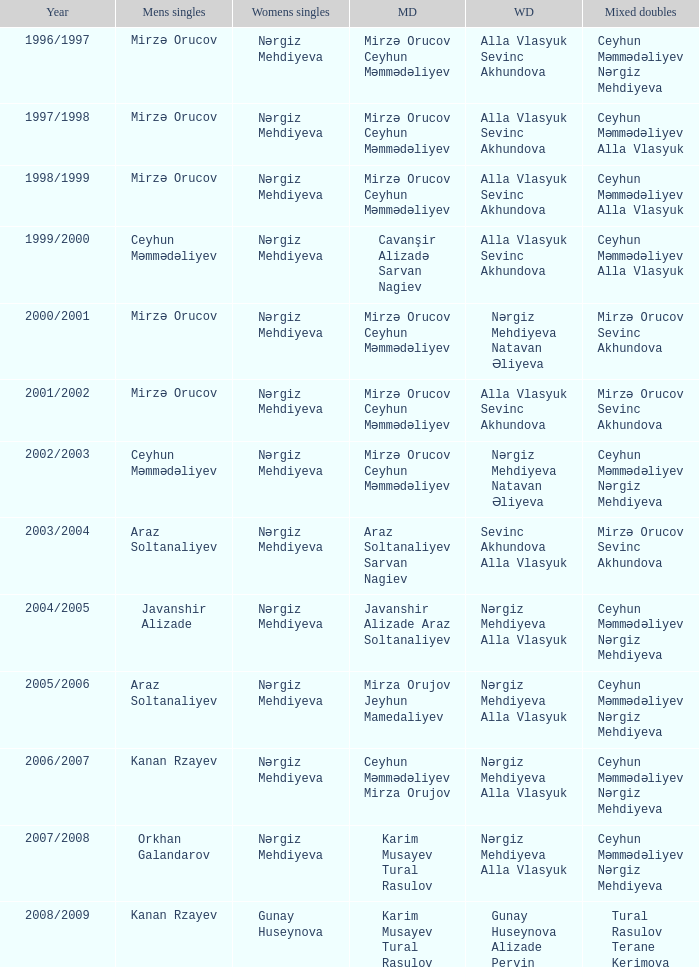What are all values for Womens Doubles in the year 2000/2001? Nərgiz Mehdiyeva Natavan Əliyeva. 